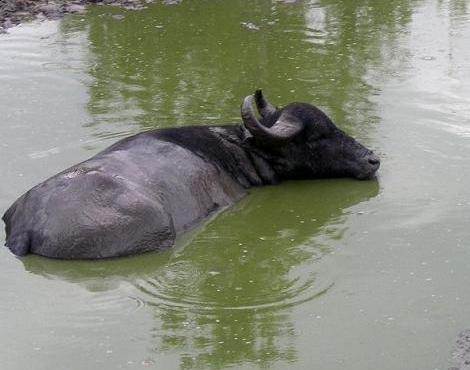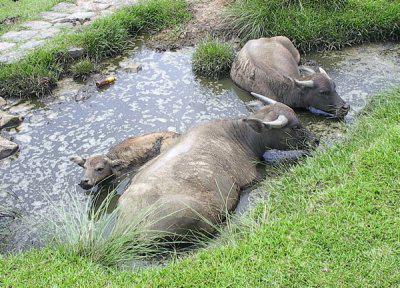The first image is the image on the left, the second image is the image on the right. For the images displayed, is the sentence "There is water in the image on the left." factually correct? Answer yes or no. Yes. 